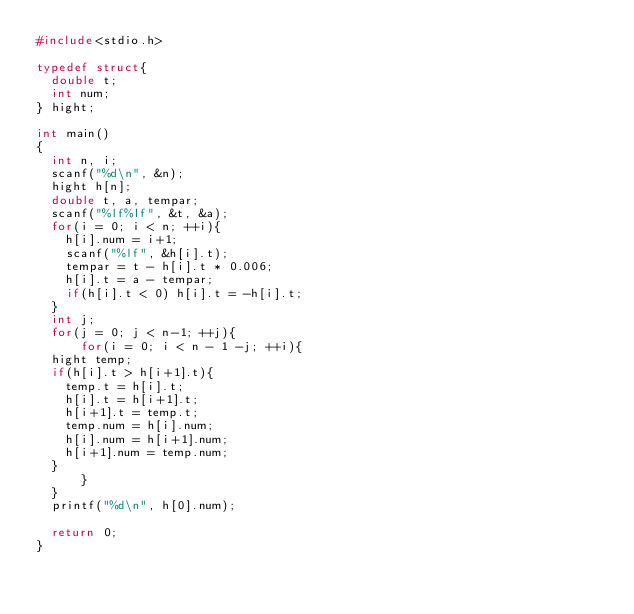Convert code to text. <code><loc_0><loc_0><loc_500><loc_500><_C_>#include<stdio.h>

typedef struct{
  double t;
  int num;
} hight;

int main()
{
  int n, i;
  scanf("%d\n", &n);
  hight h[n];
  double t, a, tempar;
  scanf("%lf%lf", &t, &a);
  for(i = 0; i < n; ++i){
    h[i].num = i+1;
    scanf("%lf", &h[i].t);
    tempar = t - h[i].t * 0.006;
    h[i].t = a - tempar;
    if(h[i].t < 0) h[i].t = -h[i].t;
  }
  int j;
  for(j = 0; j < n-1; ++j){
      for(i = 0; i < n - 1 -j; ++i){
	hight temp;
	if(h[i].t > h[i+1].t){
	  temp.t = h[i].t;
	  h[i].t = h[i+1].t;
	  h[i+1].t = temp.t;
	  temp.num = h[i].num;
	  h[i].num = h[i+1].num;
	  h[i+1].num = temp.num;
	}
      }
  }
  printf("%d\n", h[0].num);
  
  return 0;
}</code> 